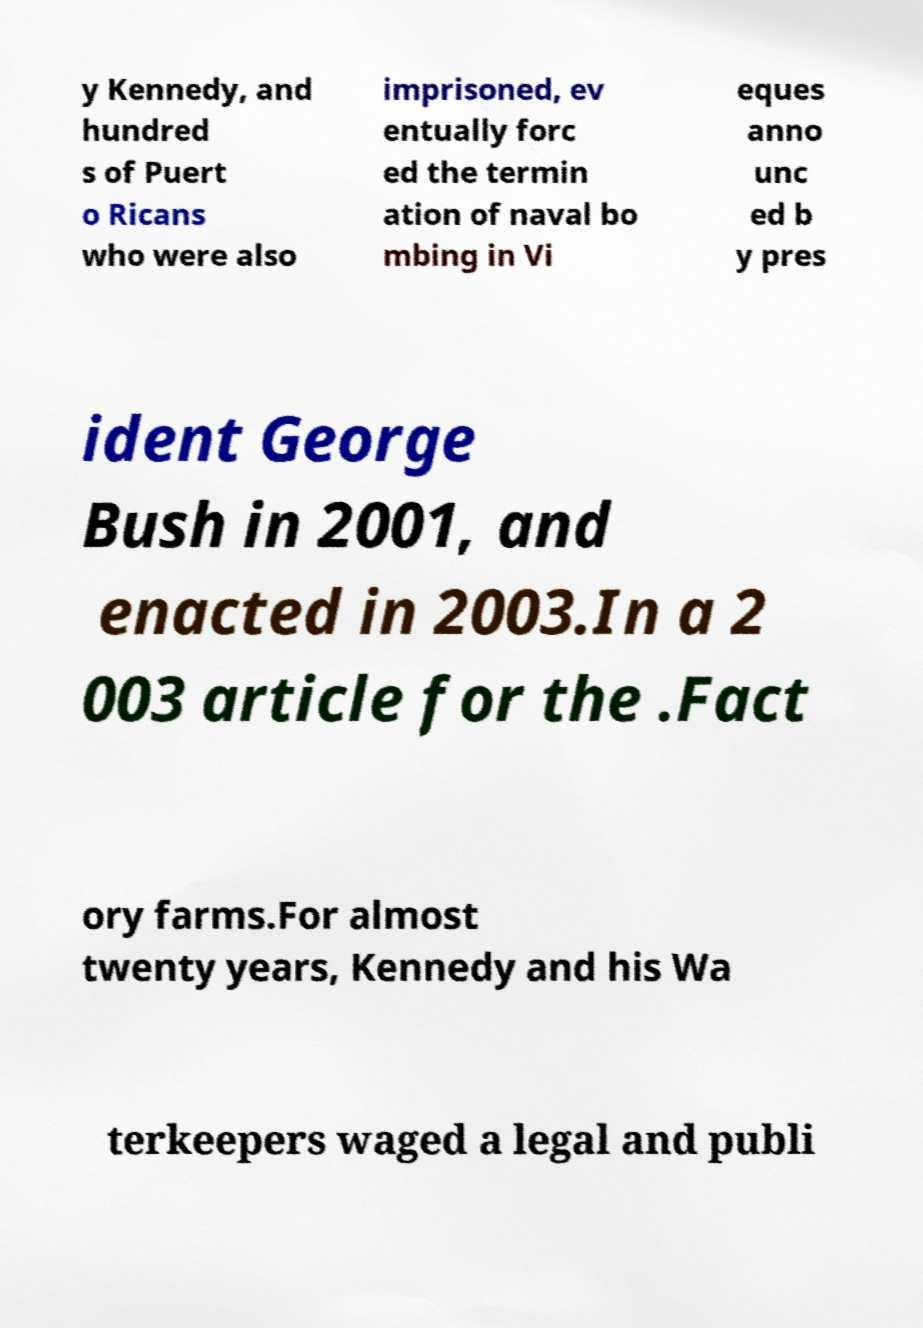Could you extract and type out the text from this image? y Kennedy, and hundred s of Puert o Ricans who were also imprisoned, ev entually forc ed the termin ation of naval bo mbing in Vi eques anno unc ed b y pres ident George Bush in 2001, and enacted in 2003.In a 2 003 article for the .Fact ory farms.For almost twenty years, Kennedy and his Wa terkeepers waged a legal and publi 